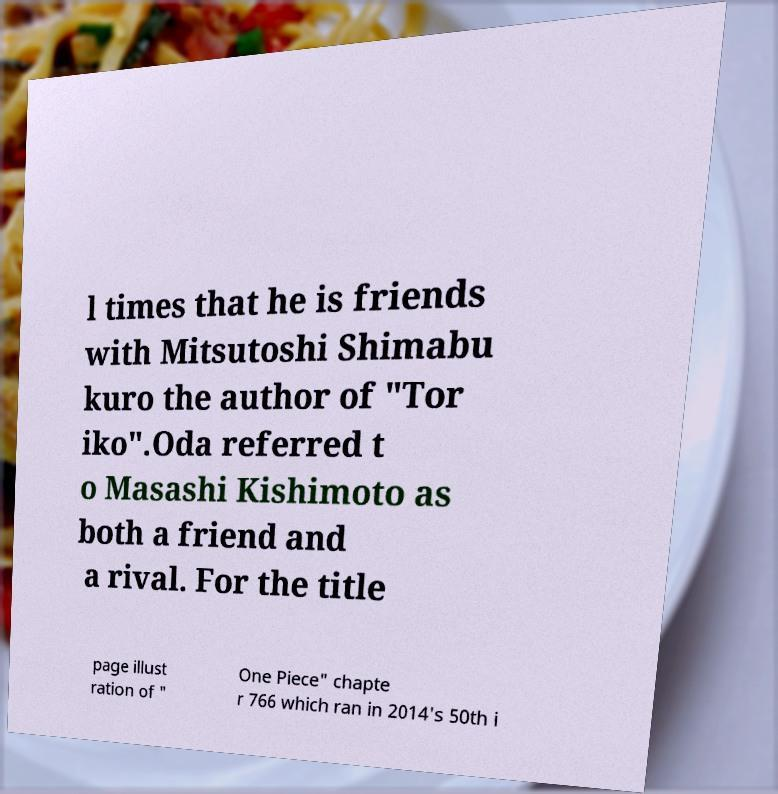What messages or text are displayed in this image? I need them in a readable, typed format. l times that he is friends with Mitsutoshi Shimabu kuro the author of "Tor iko".Oda referred t o Masashi Kishimoto as both a friend and a rival. For the title page illust ration of " One Piece" chapte r 766 which ran in 2014's 50th i 